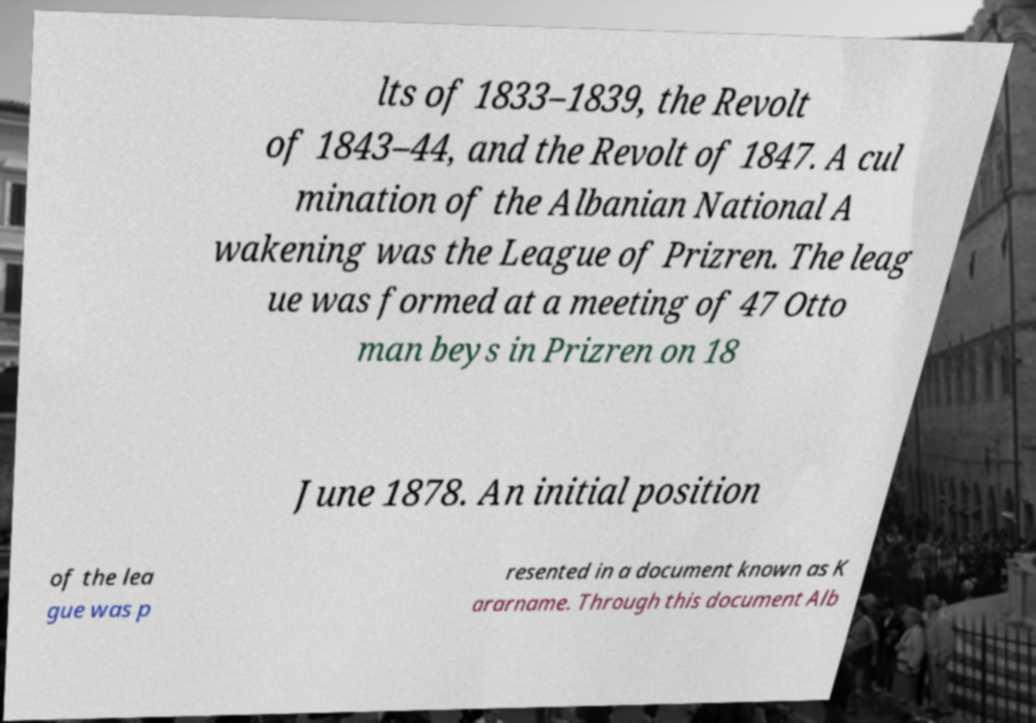Please read and relay the text visible in this image. What does it say? lts of 1833–1839, the Revolt of 1843–44, and the Revolt of 1847. A cul mination of the Albanian National A wakening was the League of Prizren. The leag ue was formed at a meeting of 47 Otto man beys in Prizren on 18 June 1878. An initial position of the lea gue was p resented in a document known as K ararname. Through this document Alb 